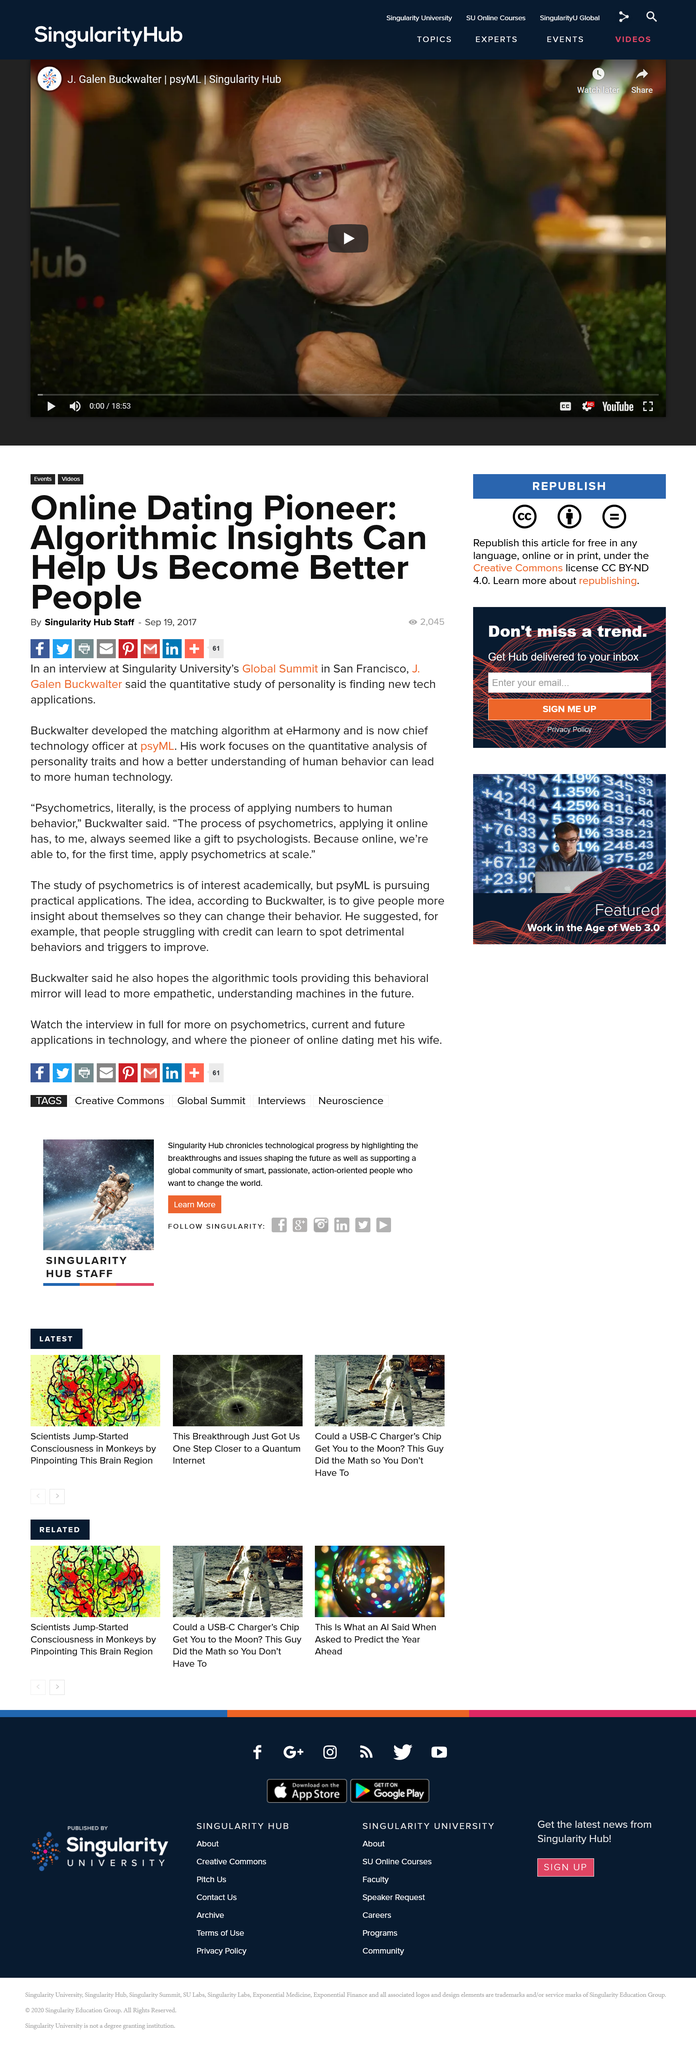Outline some significant characteristics in this image. Galen Buckwalter asserts that the purpose of quantitative study of personality is to discover new technological applications. The matching algorithm was developed by Dr. Alan E. Buckwalter's work focuses on the quantitative analysis of personality traits, with a goal of creating technology that is more human-centric by better understanding human behavior. 